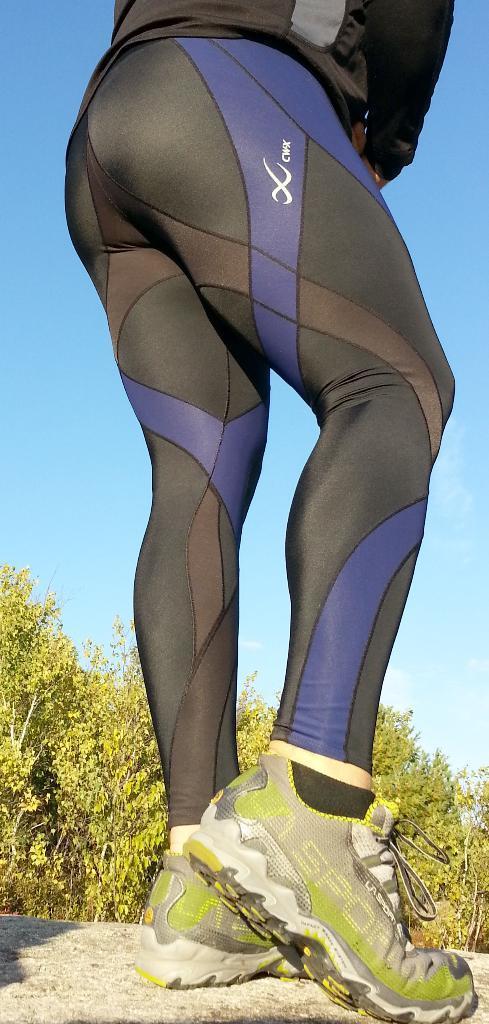What is located in the front of the image? There is a person standing in the front of the image. What type of natural scenery can be seen in the background of the image? There are trees in the background of the image. What type of pail is being used by the person in the image? There is no pail visible in the image; only the person and trees are present. How many noses can be seen on the person in the image? The person in the image has only one nose, as humans typically have one nose. 